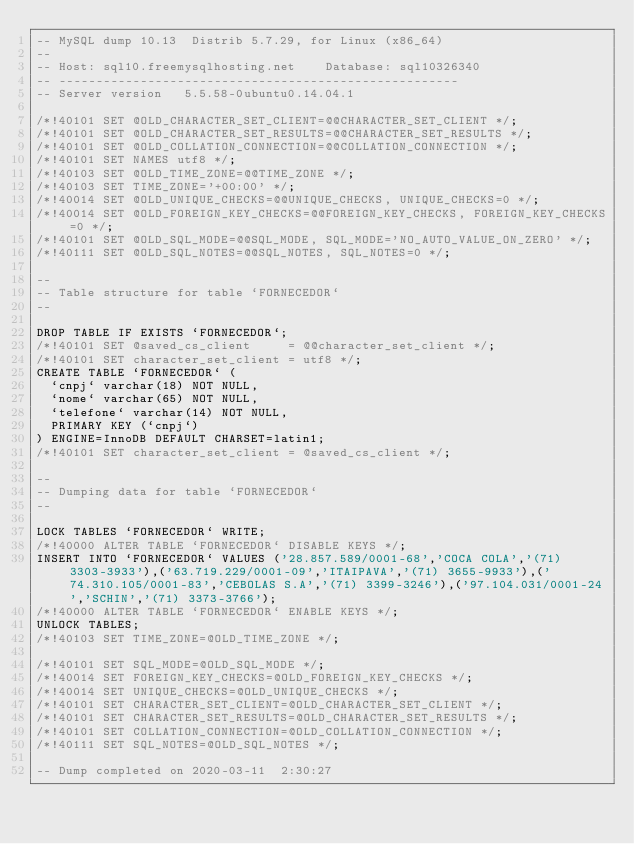<code> <loc_0><loc_0><loc_500><loc_500><_SQL_>-- MySQL dump 10.13  Distrib 5.7.29, for Linux (x86_64)
--
-- Host: sql10.freemysqlhosting.net    Database: sql10326340
-- ------------------------------------------------------
-- Server version	5.5.58-0ubuntu0.14.04.1

/*!40101 SET @OLD_CHARACTER_SET_CLIENT=@@CHARACTER_SET_CLIENT */;
/*!40101 SET @OLD_CHARACTER_SET_RESULTS=@@CHARACTER_SET_RESULTS */;
/*!40101 SET @OLD_COLLATION_CONNECTION=@@COLLATION_CONNECTION */;
/*!40101 SET NAMES utf8 */;
/*!40103 SET @OLD_TIME_ZONE=@@TIME_ZONE */;
/*!40103 SET TIME_ZONE='+00:00' */;
/*!40014 SET @OLD_UNIQUE_CHECKS=@@UNIQUE_CHECKS, UNIQUE_CHECKS=0 */;
/*!40014 SET @OLD_FOREIGN_KEY_CHECKS=@@FOREIGN_KEY_CHECKS, FOREIGN_KEY_CHECKS=0 */;
/*!40101 SET @OLD_SQL_MODE=@@SQL_MODE, SQL_MODE='NO_AUTO_VALUE_ON_ZERO' */;
/*!40111 SET @OLD_SQL_NOTES=@@SQL_NOTES, SQL_NOTES=0 */;

--
-- Table structure for table `FORNECEDOR`
--

DROP TABLE IF EXISTS `FORNECEDOR`;
/*!40101 SET @saved_cs_client     = @@character_set_client */;
/*!40101 SET character_set_client = utf8 */;
CREATE TABLE `FORNECEDOR` (
  `cnpj` varchar(18) NOT NULL,
  `nome` varchar(65) NOT NULL,
  `telefone` varchar(14) NOT NULL,
  PRIMARY KEY (`cnpj`)
) ENGINE=InnoDB DEFAULT CHARSET=latin1;
/*!40101 SET character_set_client = @saved_cs_client */;

--
-- Dumping data for table `FORNECEDOR`
--

LOCK TABLES `FORNECEDOR` WRITE;
/*!40000 ALTER TABLE `FORNECEDOR` DISABLE KEYS */;
INSERT INTO `FORNECEDOR` VALUES ('28.857.589/0001-68','COCA COLA','(71) 3303-3933'),('63.719.229/0001-09','ITAIPAVA','(71) 3655-9933'),('74.310.105/0001-83','CEBOLAS S.A','(71) 3399-3246'),('97.104.031/0001-24','SCHIN','(71) 3373-3766');
/*!40000 ALTER TABLE `FORNECEDOR` ENABLE KEYS */;
UNLOCK TABLES;
/*!40103 SET TIME_ZONE=@OLD_TIME_ZONE */;

/*!40101 SET SQL_MODE=@OLD_SQL_MODE */;
/*!40014 SET FOREIGN_KEY_CHECKS=@OLD_FOREIGN_KEY_CHECKS */;
/*!40014 SET UNIQUE_CHECKS=@OLD_UNIQUE_CHECKS */;
/*!40101 SET CHARACTER_SET_CLIENT=@OLD_CHARACTER_SET_CLIENT */;
/*!40101 SET CHARACTER_SET_RESULTS=@OLD_CHARACTER_SET_RESULTS */;
/*!40101 SET COLLATION_CONNECTION=@OLD_COLLATION_CONNECTION */;
/*!40111 SET SQL_NOTES=@OLD_SQL_NOTES */;

-- Dump completed on 2020-03-11  2:30:27
</code> 